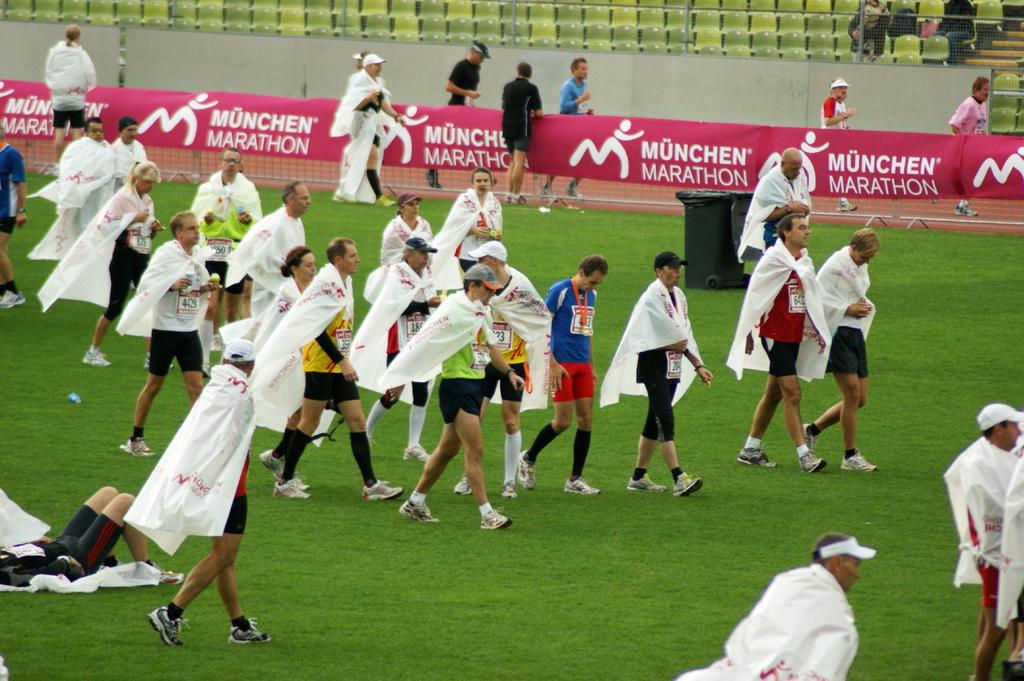What is the name of this marathon?
Your answer should be compact. Munchen. What is on the banner?
Provide a short and direct response. Munchen marathon. 